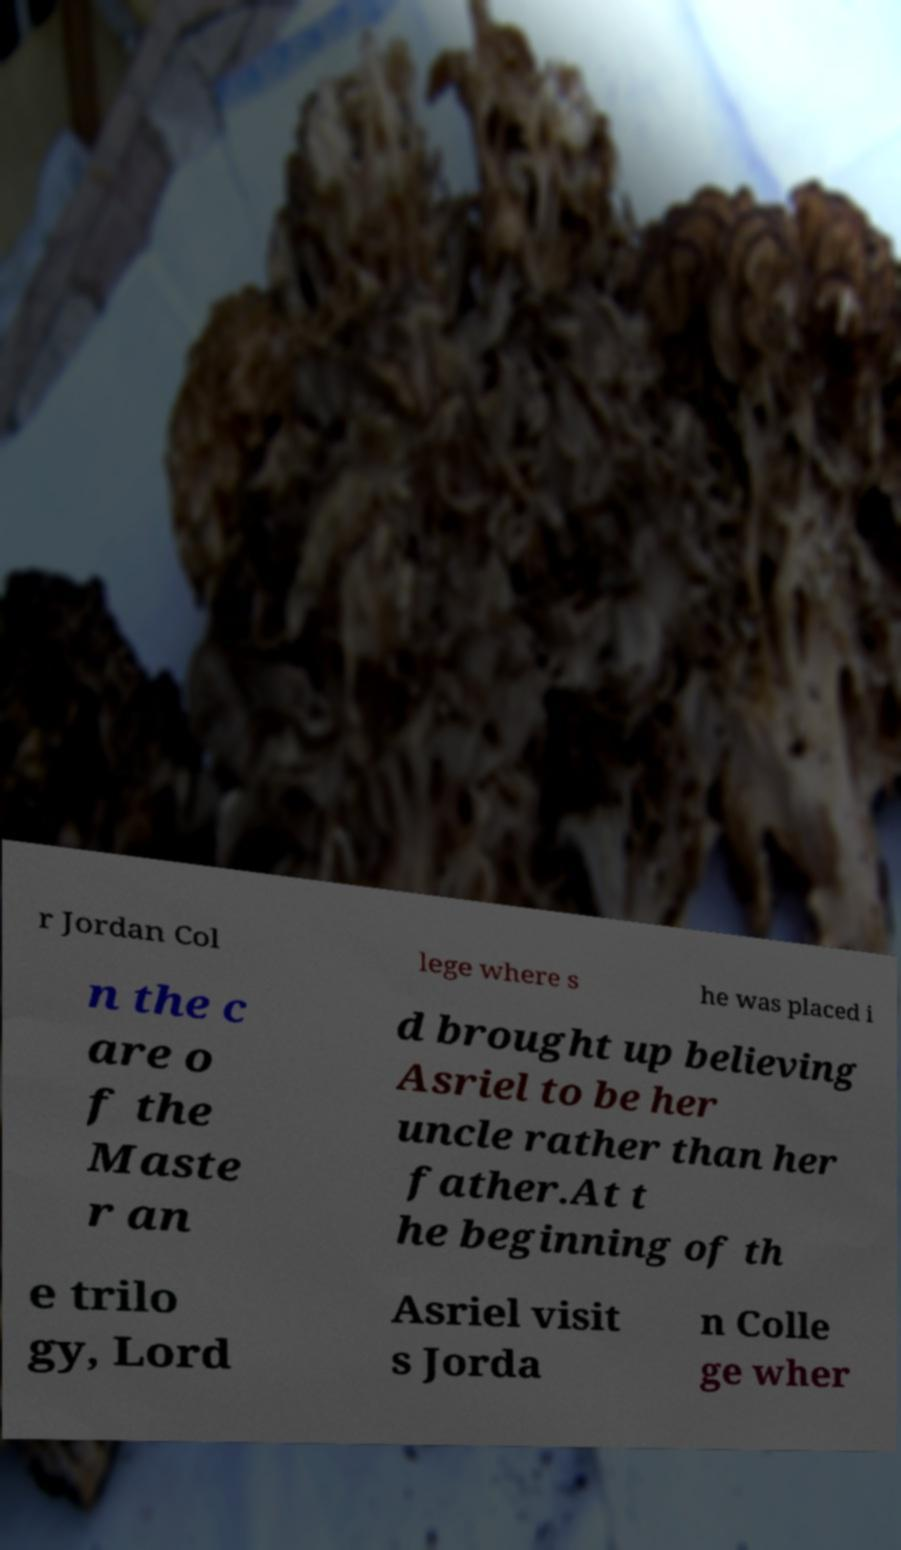What messages or text are displayed in this image? I need them in a readable, typed format. r Jordan Col lege where s he was placed i n the c are o f the Maste r an d brought up believing Asriel to be her uncle rather than her father.At t he beginning of th e trilo gy, Lord Asriel visit s Jorda n Colle ge wher 